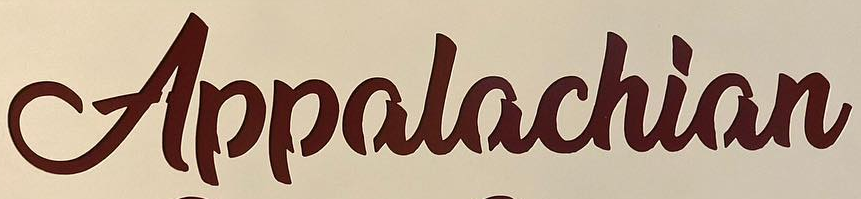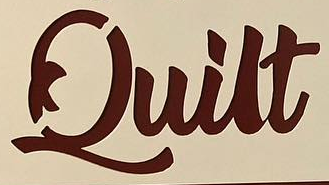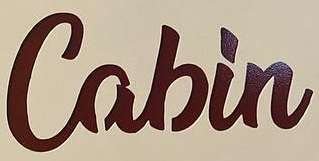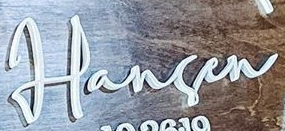Read the text content from these images in order, separated by a semicolon. Appalachian; Quilt; Cabin; Harsen 